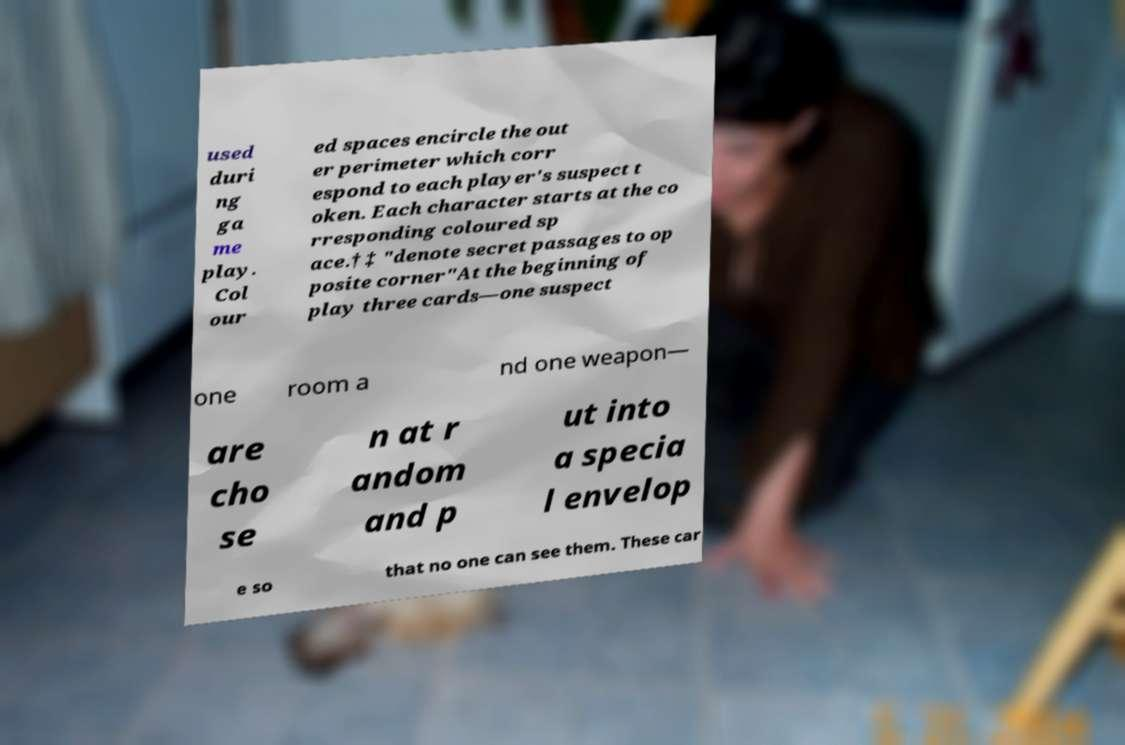For documentation purposes, I need the text within this image transcribed. Could you provide that? used duri ng ga me play. Col our ed spaces encircle the out er perimeter which corr espond to each player's suspect t oken. Each character starts at the co rresponding coloured sp ace.† ‡ "denote secret passages to op posite corner"At the beginning of play three cards—one suspect one room a nd one weapon— are cho se n at r andom and p ut into a specia l envelop e so that no one can see them. These car 